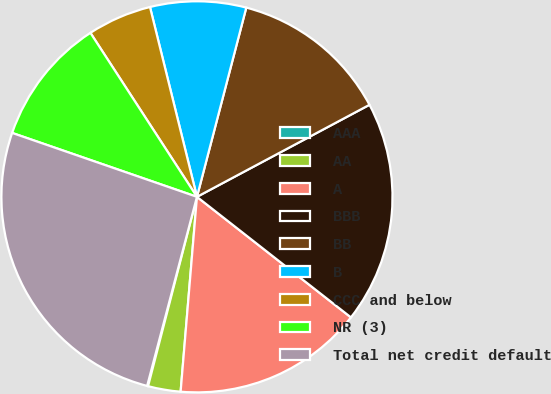<chart> <loc_0><loc_0><loc_500><loc_500><pie_chart><fcel>AAA<fcel>AA<fcel>A<fcel>BBB<fcel>BB<fcel>B<fcel>CCC and below<fcel>NR (3)<fcel>Total net credit default<nl><fcel>0.08%<fcel>2.69%<fcel>15.76%<fcel>18.37%<fcel>13.14%<fcel>7.92%<fcel>5.31%<fcel>10.53%<fcel>26.2%<nl></chart> 